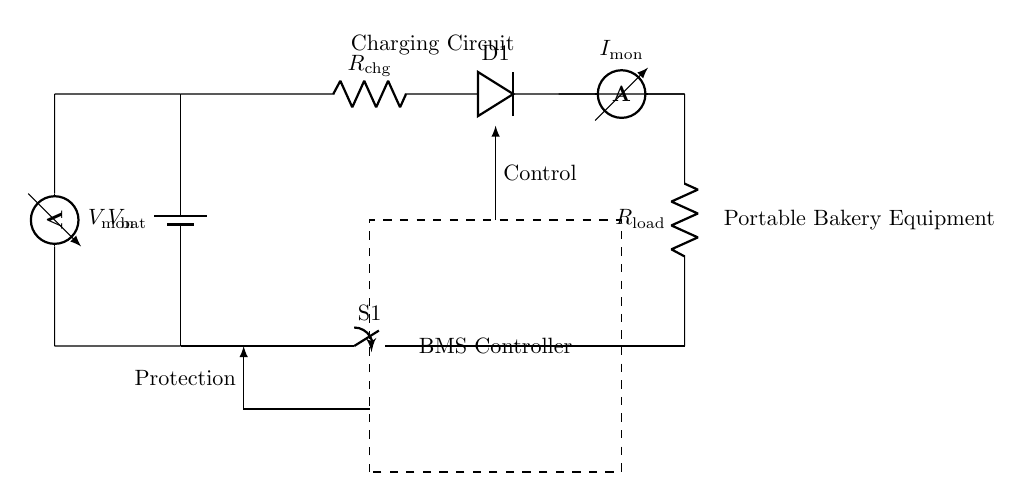What component is used for current monitoring? The component used for current monitoring in this circuit is an ammeter, which measures the current flowing through the circuit.
Answer: ammeter What is the value of the load resistance? The load resistance is denoted as R_load in the diagram, indicating its presence but not its numerical value. It can vary depending on the application of the portable bakery equipment.
Answer: R_load What is the function of the switch labeled S1? The switch labeled S1 acts as a protection circuit, allowing for the control of the current flow to the load. When opened, it disconnects the load from the battery and charging circuit.
Answer: protection circuit What signals does the controller manage in this circuit? The controller manages control signals and protection signals. Control signals regulate the charging process, while protection signals prevent overcharging or other damaging conditions.
Answer: Control and protection How many resistors are present in the charging circuit? There are two resistors present in the charging circuit: one is labeled R_chg as part of the charging path, and the other is R_load connected to the load.
Answer: two What is being monitored by the voltmeter? The voltmeter, labeled V_mon, monitors the voltage across the battery, providing insights into the state of charge and ensuring it remains within a safe level.
Answer: battery voltage What is the role of the diode in this circuit? The diode, labeled D1 in the diagram, allows current to flow in only one direction. It prevents backflow from the load to the battery when charging, thus protecting the battery.
Answer: prevent backflow 